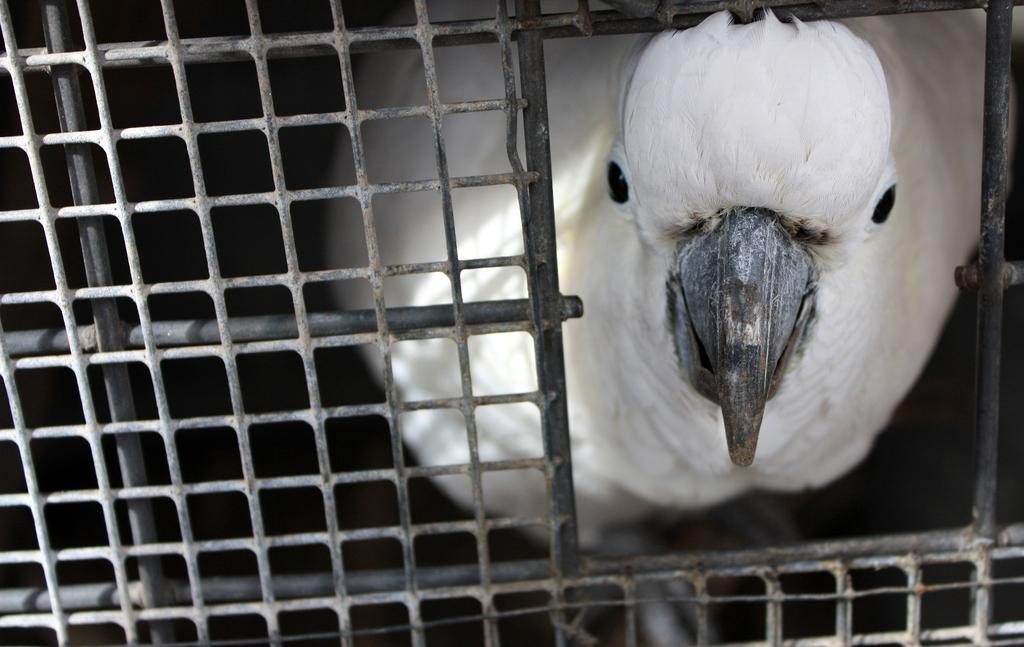What type of animal is in the image? There is a white color bird in the image. Where is the bird located? The bird is in a metal cage. What type of love is the bird expressing towards its sister in the image? There is no indication of love or a sister in the image; it only features a bird in a metal cage. 